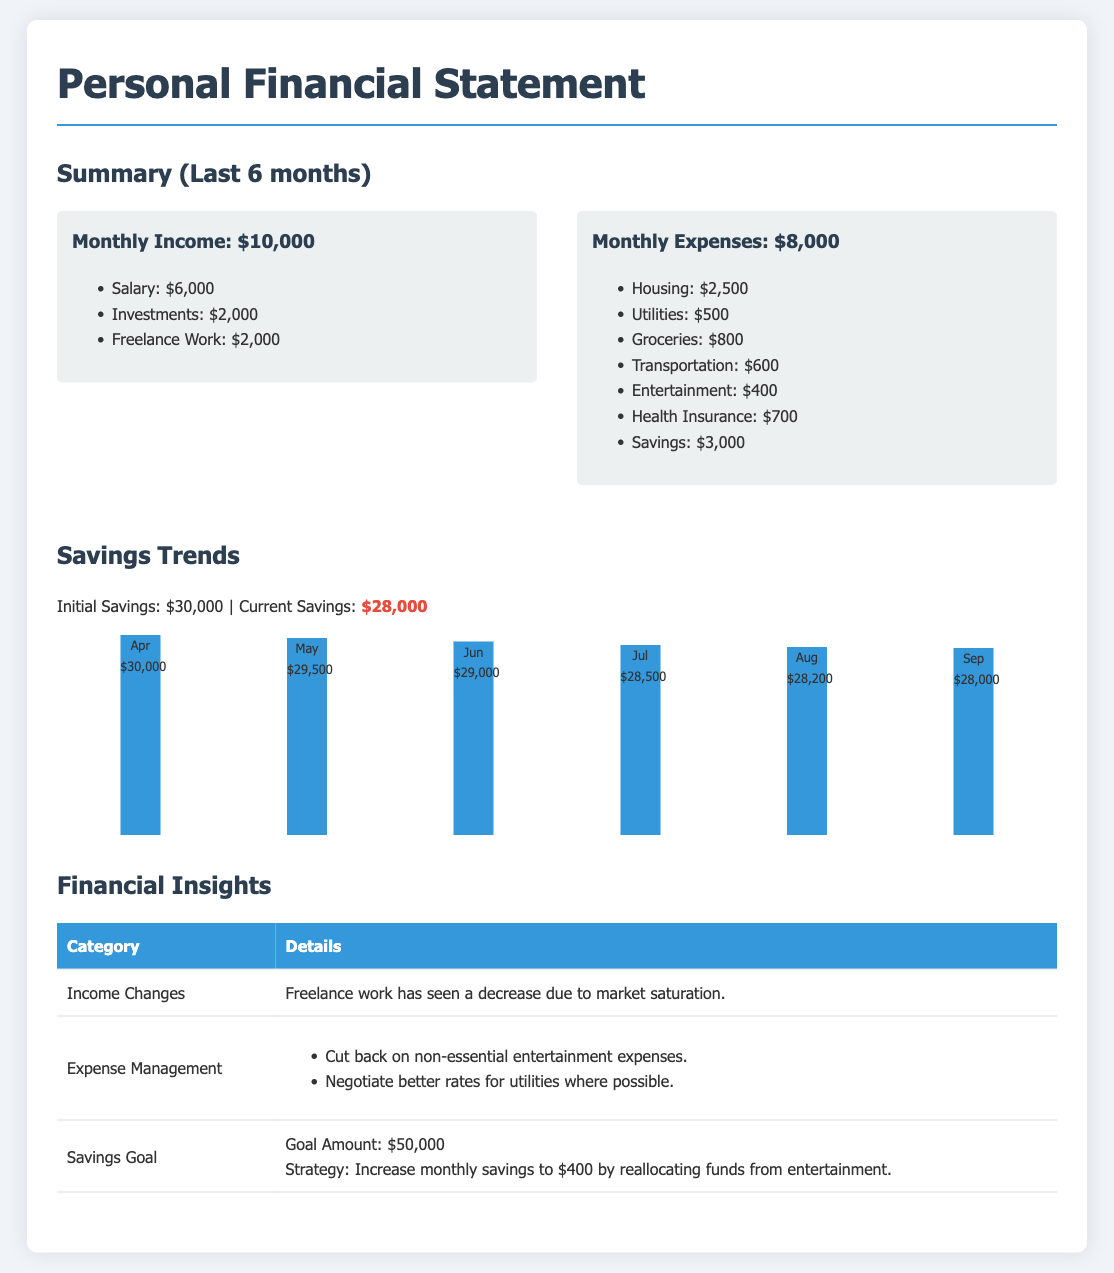What is the monthly income? The monthly income is given in the document and is listed as $10,000.
Answer: $10,000 What is the total amount spent on housing? The document outlines that housing expenses amount to $2,500.
Answer: $2,500 What is the initial savings amount? The initial savings is stated in the document as $30,000.
Answer: $30,000 What strategy is suggested to increase savings? The document mentions reallocating funds from entertainment to increase savings.
Answer: Reallocate funds from entertainment What is the current savings amount? The current savings amount shown in the document is $28,000.
Answer: $28,000 How much did savings decrease in total over six months? The savings went from $30,000 to $28,000, indicating a decrease of $2,000.
Answer: $2,000 What was the expense for health insurance? The document lists health insurance expenses as $700.
Answer: $700 What was one of the reasons for income changes? The document specifies that a decrease in freelance work is due to market saturation.
Answer: Market saturation What is the savings goal amount? The document states the savings goal amount as $50,000.
Answer: $50,000 